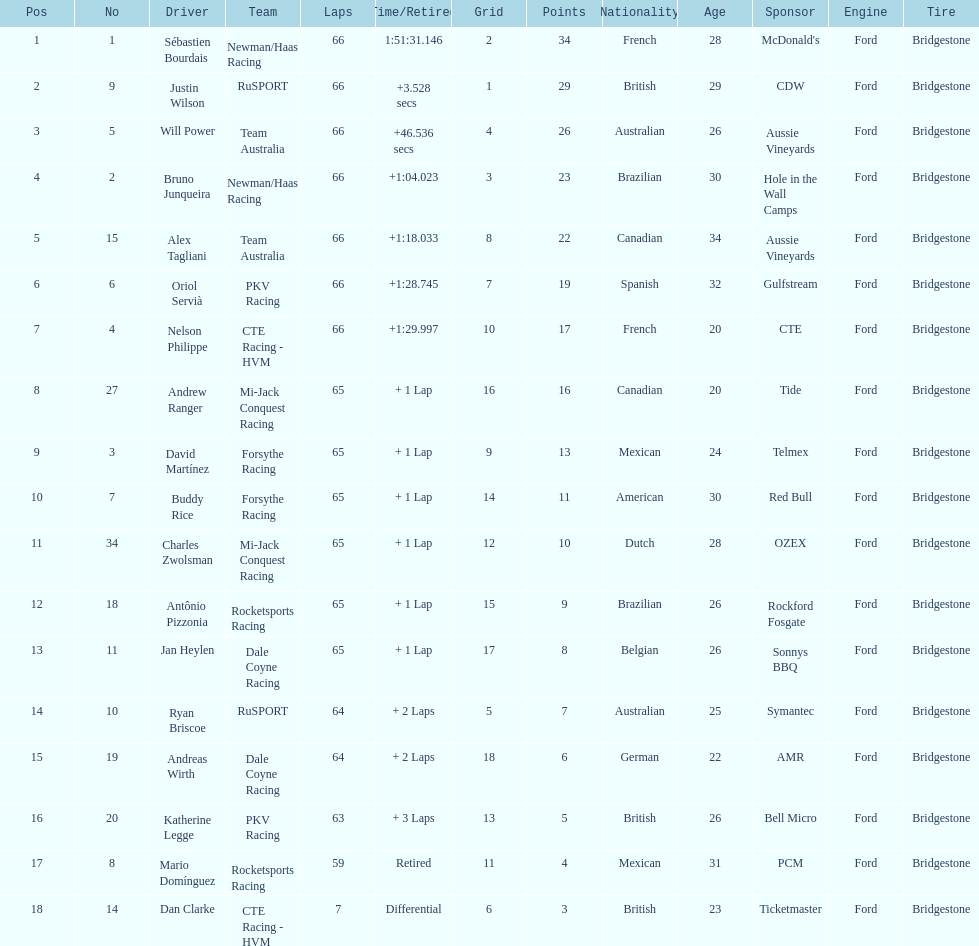Who finished directly after the driver who finished in 1:28.745? Nelson Philippe. 